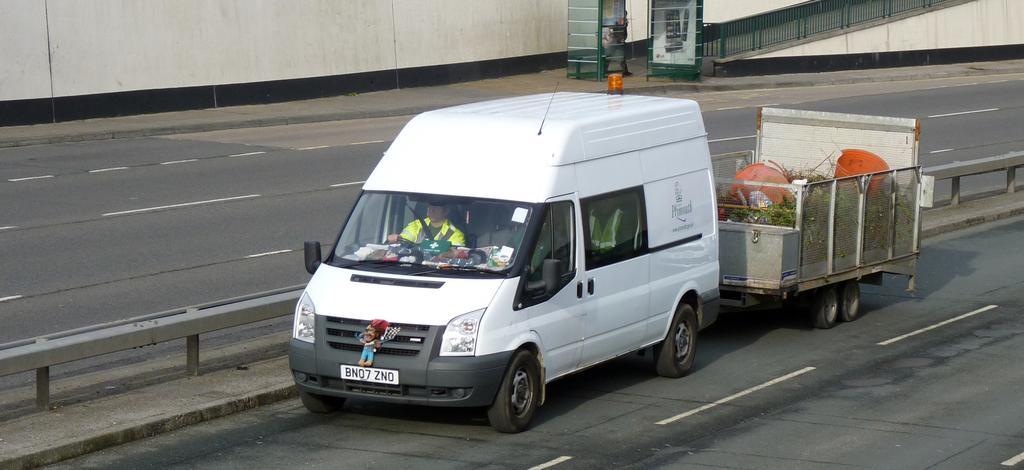In one or two sentences, can you explain what this image depicts? In this image, we can see few people are riding a vehicle on the road. Here we can see few objects in the mesh container. Here we can see rods and roads. Top of the image, we can see wall, boxes, and railing. Here we can see a person is walking. 